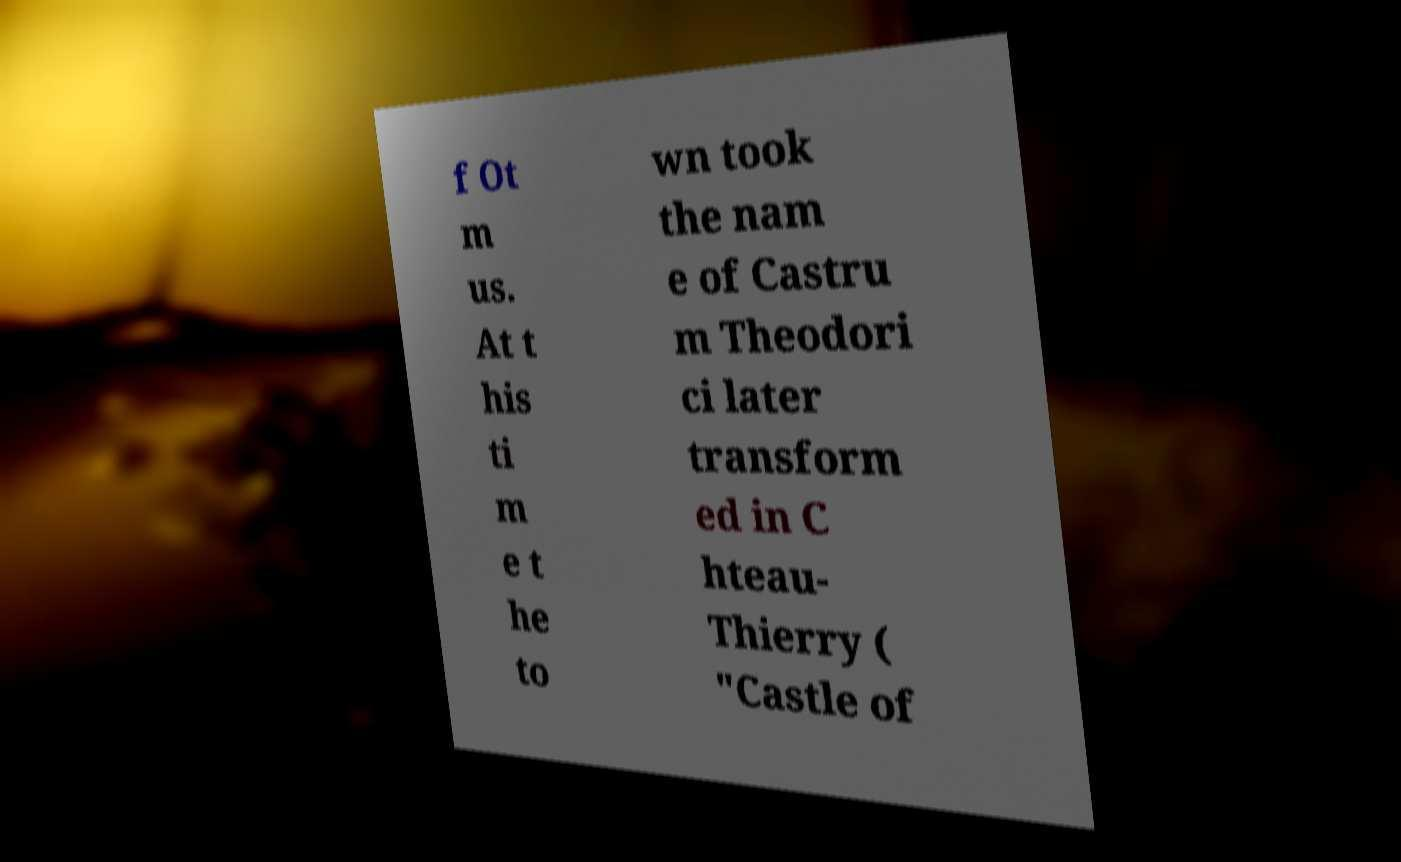Could you assist in decoding the text presented in this image and type it out clearly? f Ot m us. At t his ti m e t he to wn took the nam e of Castru m Theodori ci later transform ed in C hteau- Thierry ( "Castle of 